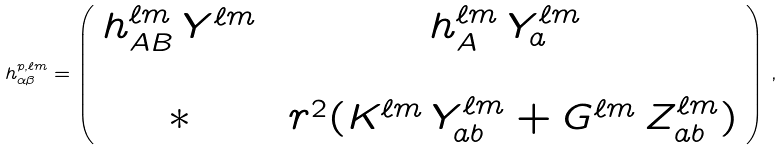<formula> <loc_0><loc_0><loc_500><loc_500>h ^ { p , \ell m } _ { \alpha \beta } = \left ( \begin{array} { c c } h _ { A B } ^ { \ell m } \, Y ^ { \ell m } & h _ { A } ^ { \ell m } \, Y ^ { \ell m } _ { a } \\ \\ \ast & \ r ^ { 2 } ( K ^ { \ell m } \, Y ^ { \ell m } _ { a b } + G ^ { \ell m } \, Z _ { a b } ^ { \ell m } ) \end{array} \right ) \, ,</formula> 